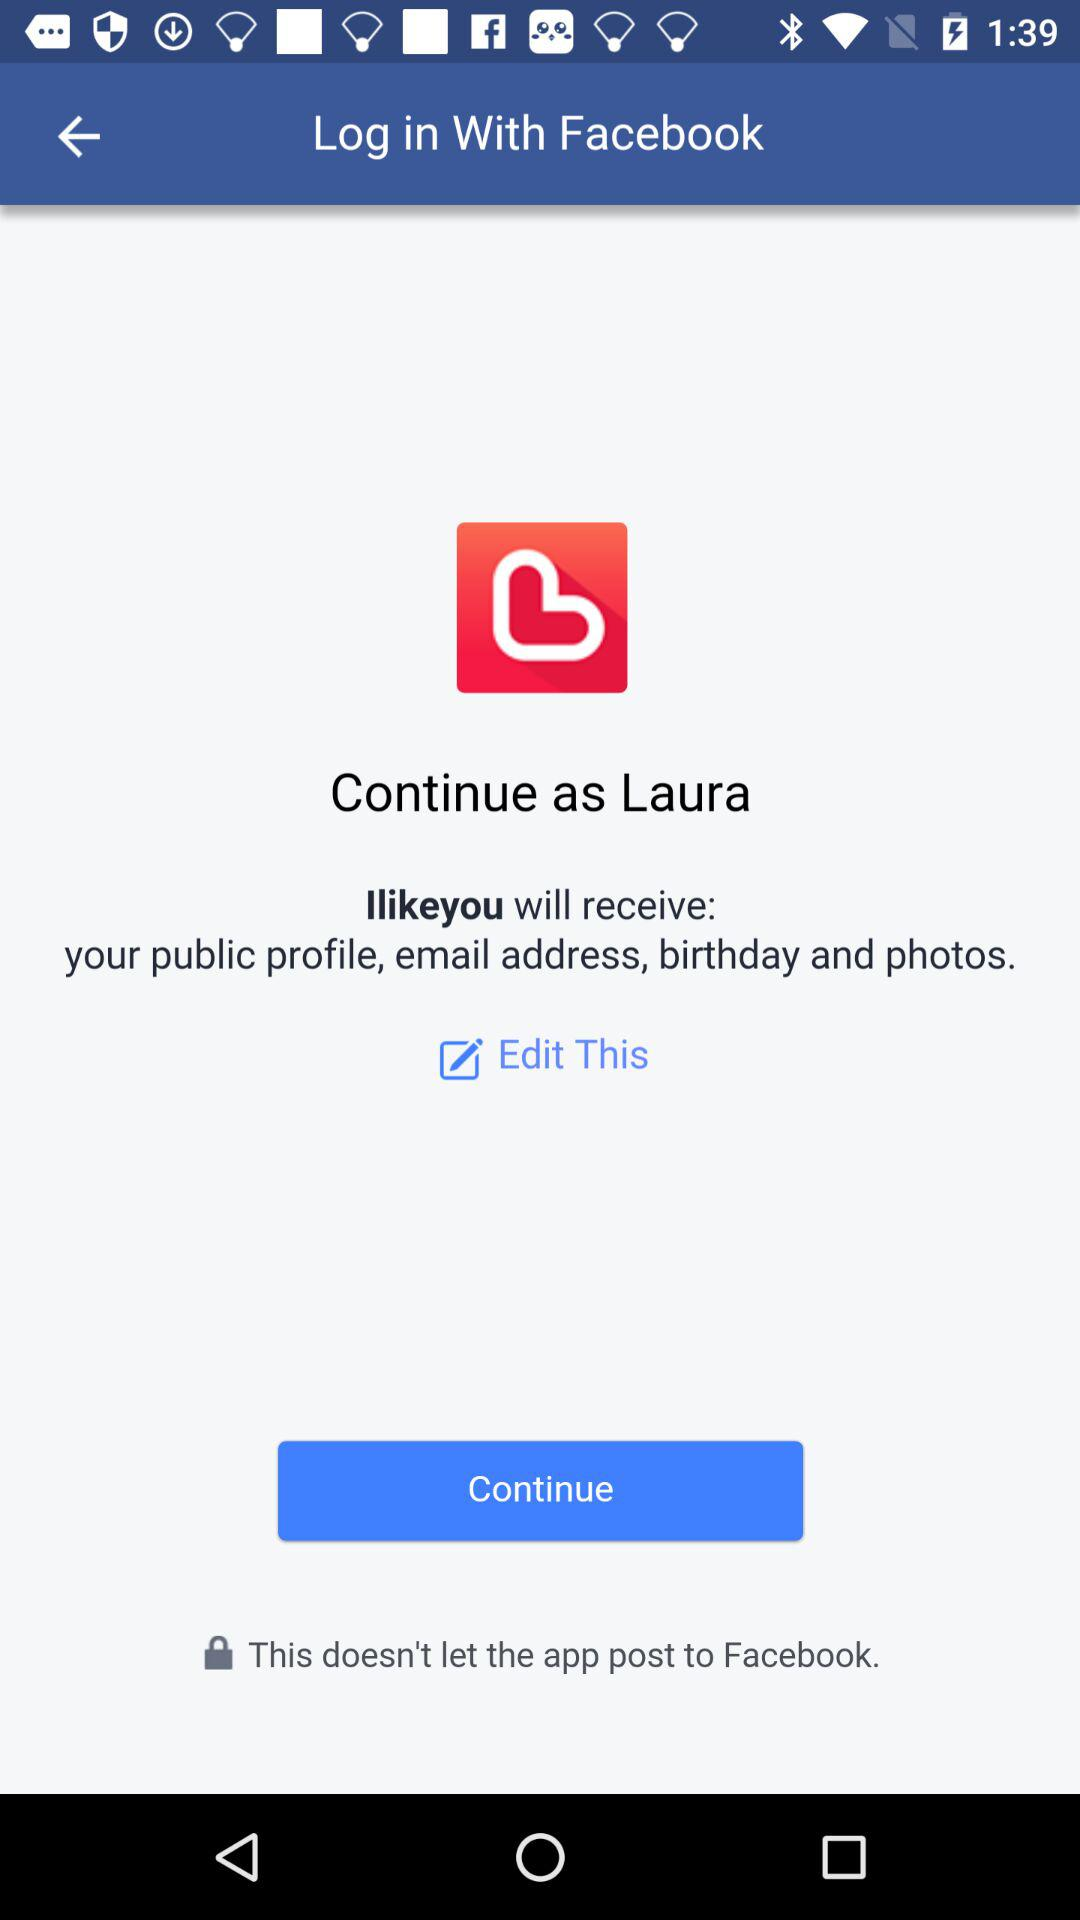What is the app name? The apps' names are "Facebook" and "Ilikeyou". 